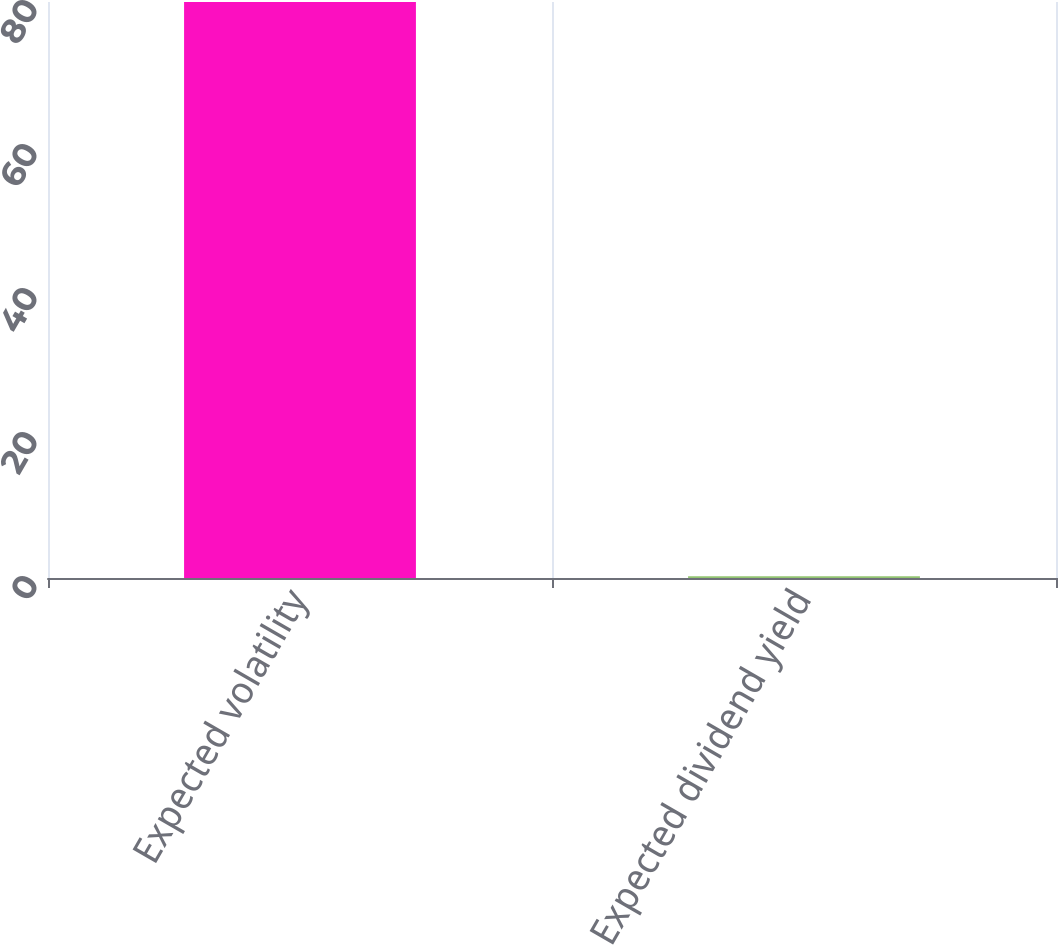Convert chart. <chart><loc_0><loc_0><loc_500><loc_500><bar_chart><fcel>Expected volatility<fcel>Expected dividend yield<nl><fcel>80<fcel>0.26<nl></chart> 